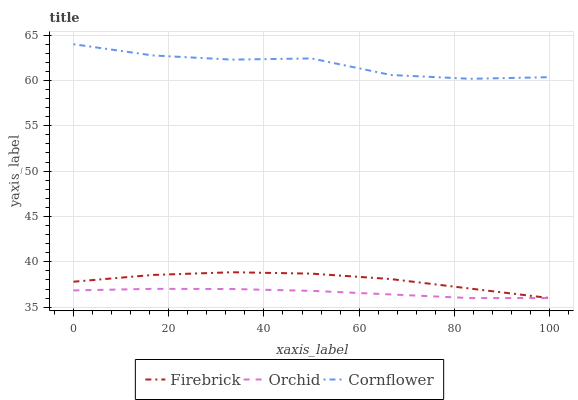Does Orchid have the minimum area under the curve?
Answer yes or no. Yes. Does Cornflower have the maximum area under the curve?
Answer yes or no. Yes. Does Firebrick have the minimum area under the curve?
Answer yes or no. No. Does Firebrick have the maximum area under the curve?
Answer yes or no. No. Is Orchid the smoothest?
Answer yes or no. Yes. Is Cornflower the roughest?
Answer yes or no. Yes. Is Firebrick the smoothest?
Answer yes or no. No. Is Firebrick the roughest?
Answer yes or no. No. Does Firebrick have the lowest value?
Answer yes or no. Yes. Does Cornflower have the highest value?
Answer yes or no. Yes. Does Firebrick have the highest value?
Answer yes or no. No. Is Orchid less than Cornflower?
Answer yes or no. Yes. Is Cornflower greater than Firebrick?
Answer yes or no. Yes. Does Firebrick intersect Orchid?
Answer yes or no. Yes. Is Firebrick less than Orchid?
Answer yes or no. No. Is Firebrick greater than Orchid?
Answer yes or no. No. Does Orchid intersect Cornflower?
Answer yes or no. No. 